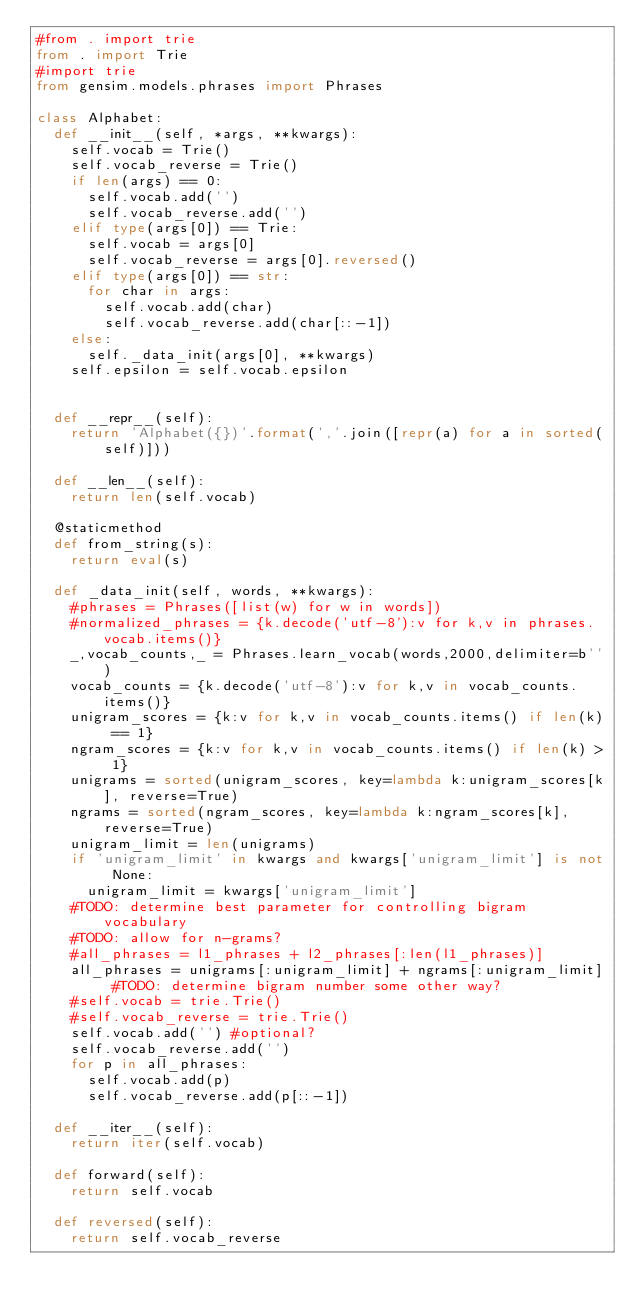<code> <loc_0><loc_0><loc_500><loc_500><_Python_>#from . import trie
from . import Trie
#import trie
from gensim.models.phrases import Phrases

class Alphabet:
  def __init__(self, *args, **kwargs):
    self.vocab = Trie()
    self.vocab_reverse = Trie()
    if len(args) == 0:
      self.vocab.add('')
      self.vocab_reverse.add('')
    elif type(args[0]) == Trie:
      self.vocab = args[0]
      self.vocab_reverse = args[0].reversed()
    elif type(args[0]) == str:
      for char in args:
        self.vocab.add(char)
        self.vocab_reverse.add(char[::-1])
    else:
      self._data_init(args[0], **kwargs)
    self.epsilon = self.vocab.epsilon


  def __repr__(self):
    return 'Alphabet({})'.format(','.join([repr(a) for a in sorted(self)]))

  def __len__(self):
    return len(self.vocab)

  @staticmethod
  def from_string(s):
    return eval(s)

  def _data_init(self, words, **kwargs):
    #phrases = Phrases([list(w) for w in words])
    #normalized_phrases = {k.decode('utf-8'):v for k,v in phrases.vocab.items()}
    _,vocab_counts,_ = Phrases.learn_vocab(words,2000,delimiter=b'')
    vocab_counts = {k.decode('utf-8'):v for k,v in vocab_counts.items()}
    unigram_scores = {k:v for k,v in vocab_counts.items() if len(k) == 1}
    ngram_scores = {k:v for k,v in vocab_counts.items() if len(k) > 1}
    unigrams = sorted(unigram_scores, key=lambda k:unigram_scores[k], reverse=True)
    ngrams = sorted(ngram_scores, key=lambda k:ngram_scores[k], reverse=True)
    unigram_limit = len(unigrams)
    if 'unigram_limit' in kwargs and kwargs['unigram_limit'] is not None:
      unigram_limit = kwargs['unigram_limit']
    #TODO: determine best parameter for controlling bigram vocabulary
    #TODO: allow for n-grams?
    #all_phrases = l1_phrases + l2_phrases[:len(l1_phrases)]
    all_phrases = unigrams[:unigram_limit] + ngrams[:unigram_limit] #TODO: determine bigram number some other way?
    #self.vocab = trie.Trie()
    #self.vocab_reverse = trie.Trie()
    self.vocab.add('') #optional?
    self.vocab_reverse.add('')
    for p in all_phrases:
      self.vocab.add(p)
      self.vocab_reverse.add(p[::-1])
  
  def __iter__(self):
    return iter(self.vocab)

  def forward(self):
    return self.vocab

  def reversed(self):
    return self.vocab_reverse



</code> 